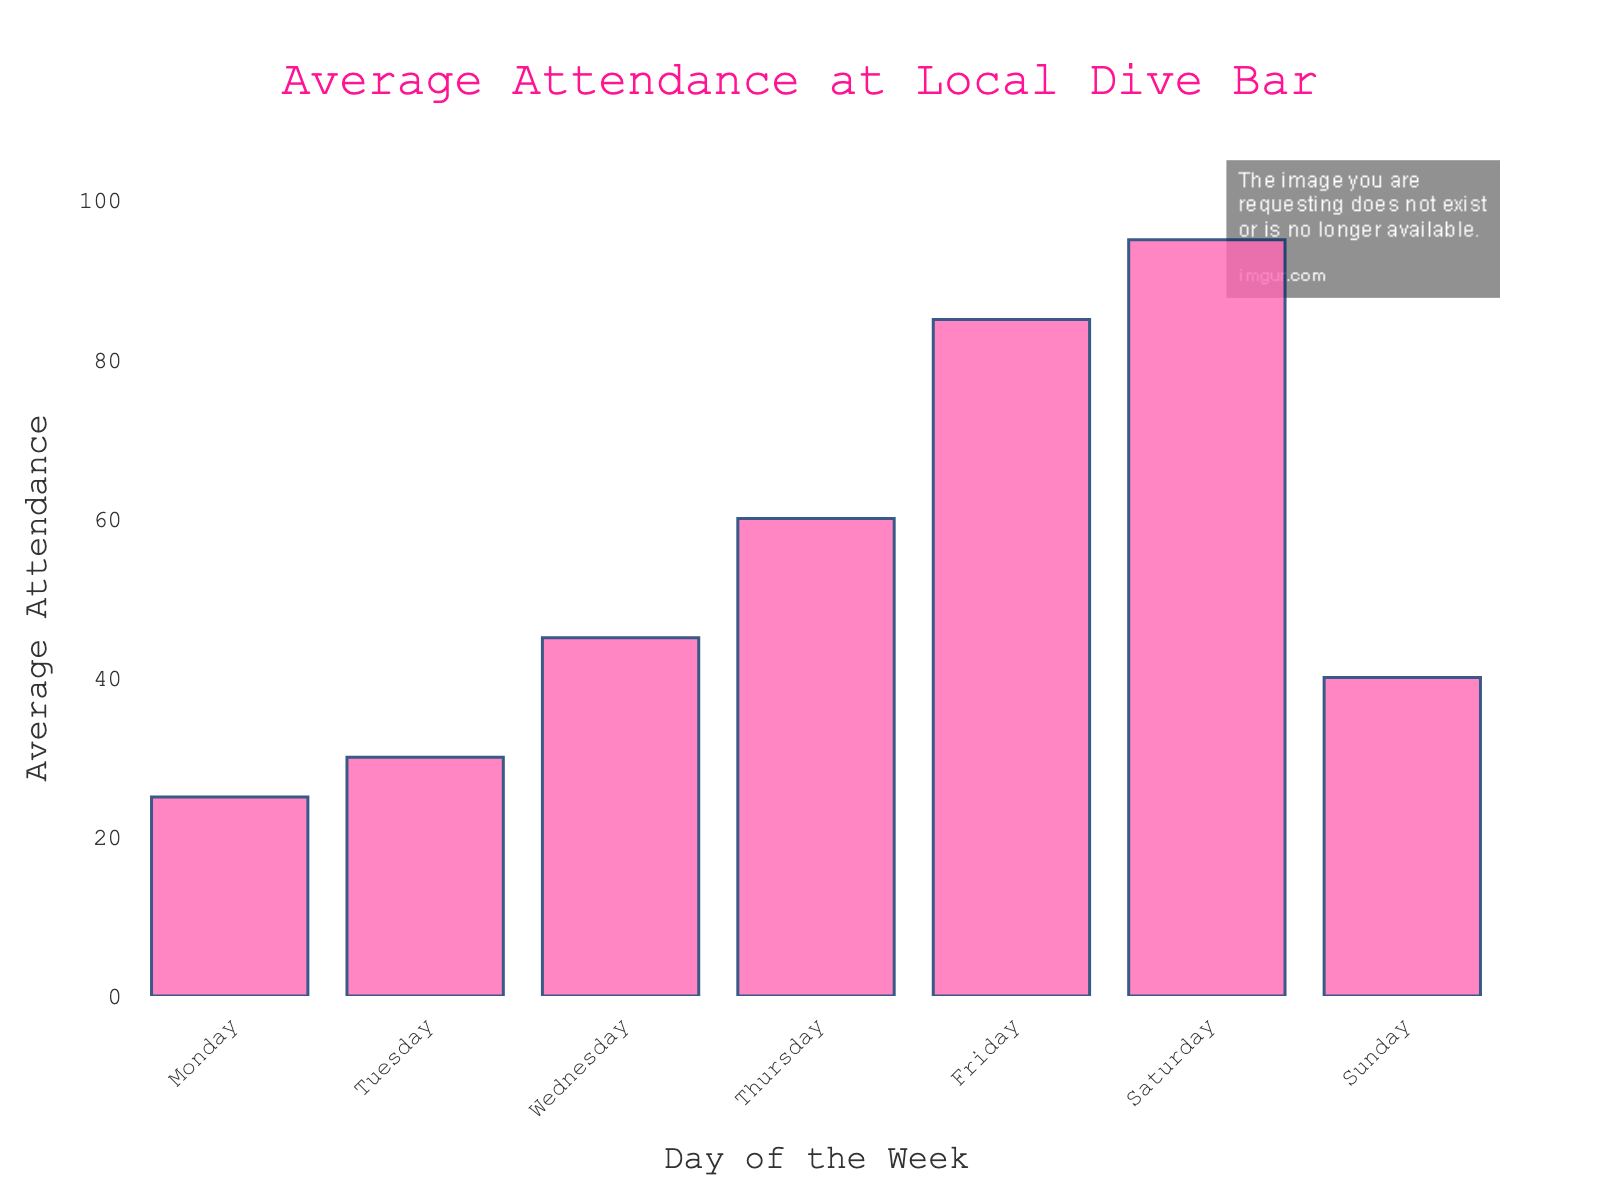What's the average attendance on weekdays (Monday to Friday) combined? The average attendance for each weekday is 25 (Monday), 30 (Tuesday), 45 (Wednesday), 60 (Thursday), and 85 (Friday). Adding these together, we get 25 + 30 + 45 + 60 + 85 = 245. There are 5 weekdays, so the average attendance is 245 / 5 = 49
Answer: 49 What's the difference in attendance between the highest and lowest day? The highest average attendance is on Saturday at 95, and the lowest is on Monday at 25. The difference is 95 - 25 = 70
Answer: 70 Which day has the lowest average attendance, and what is it? By looking at the heights of the bars, Monday has the lowest average attendance at 25
Answer: Monday, 25 Are the attendances higher on weekends compared to weekdays? The total attendance for weekends (Saturday and Sunday) is 95 + 40 = 135. For weekdays (Monday to Friday), the total is 25 + 30 + 45 + 60 + 85 = 245. Note that there are 2 weekends and 5 weekdays, calculating the average for each; weekdays: 245 / 5 = 49, weekends: 135 / 2 = 67.5. The average attendance is higher on weekends (67.5) compared to weekdays (49)
Answer: Yes, 67.5 vs 49 How does the attendance on Thursday compare to the attendance on Tuesday? The average attendance on Thursday is 60, while on Tuesday it is 30. So, Thursday has 60 - 30 = 30 more attendees
Answer: 30 more What is the total attendance over the whole week? The total attendance is the sum of all the day's averages: 25 (Monday) + 30 (Tuesday) + 45 (Wednesday) + 60 (Thursday) + 85 (Friday) + 95 (Saturday) + 40 (Sunday) = 380
Answer: 380 If the bar hopes to maintain 50 average attendees daily, on which days do they exceed this number? Days with average attendance more than 50 are Thursday (60), Friday (85), and Saturday (95)
Answer: Thursday, Friday, Saturday What trend do you observe from Monday to Sunday in the bar's attendance? The attendance tends to increase from Monday (25) to Saturday (95), then drops on Sunday (40). This shows a peak on Saturday with a consistent rise from the start of the week and a fall towards the end
Answer: Increase until Saturday, then a decrease Which days have attendance between 30 and 60? We observe the heights of the bars for Tuesday, Wednesday, and Thursday, which have average attendances of 30, 45, and 60 respectively
Answer: Tuesday, Wednesday, Thursday Comparing Monday to Wednesday, how much does attendance increase? The attendance on Monday is 25, and on Wednesday it is 45. The increase is 45 - 25 = 20 attendees
Answer: 20 